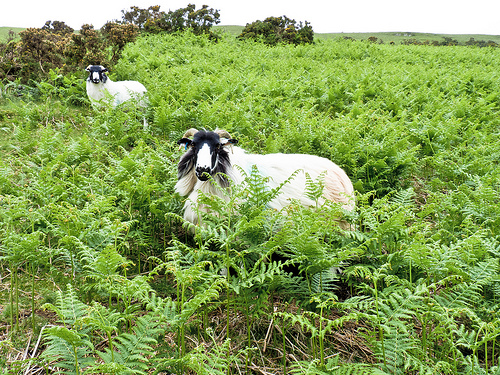Please provide a short description for this region: [0.39, 0.19, 1.0, 0.38]. This section vividly displays a lush area teeming with leafy plants, their vibrant green shades suggesting healthy vegetation likely nurtured by adequate rainfall. 